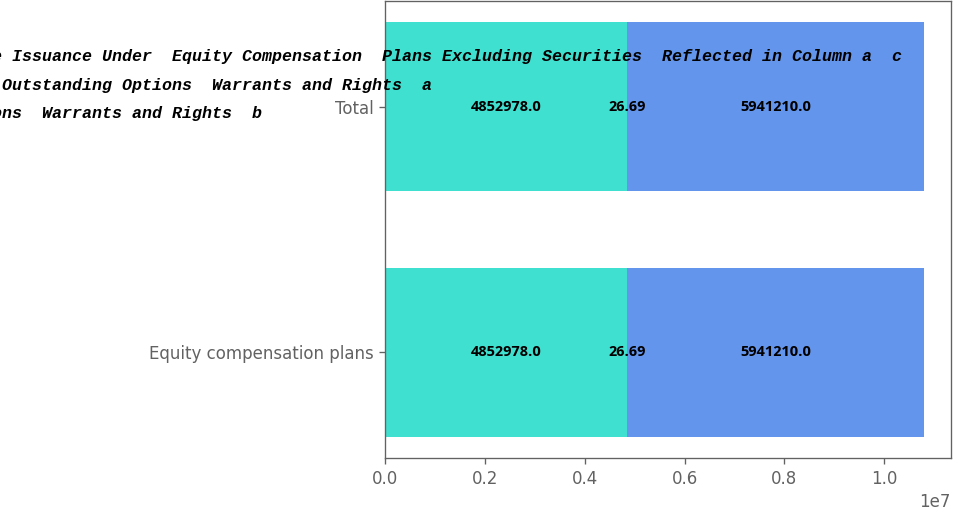<chart> <loc_0><loc_0><loc_500><loc_500><stacked_bar_chart><ecel><fcel>Equity compensation plans<fcel>Total<nl><fcel>Number of Securities  Remaining Available for  Future Issuance Under  Equity Compensation  Plans Excluding Securities  Reflected in Column a  c<fcel>4.85298e+06<fcel>4.85298e+06<nl><fcel>Number of Securities to  be Issued Upon Exercise  of Outstanding Options  Warrants and Rights  a<fcel>26.69<fcel>26.69<nl><fcel>WeightedAverage  Exercise Price of  Outstanding Options  Warrants and Rights  b<fcel>5.94121e+06<fcel>5.94121e+06<nl></chart> 